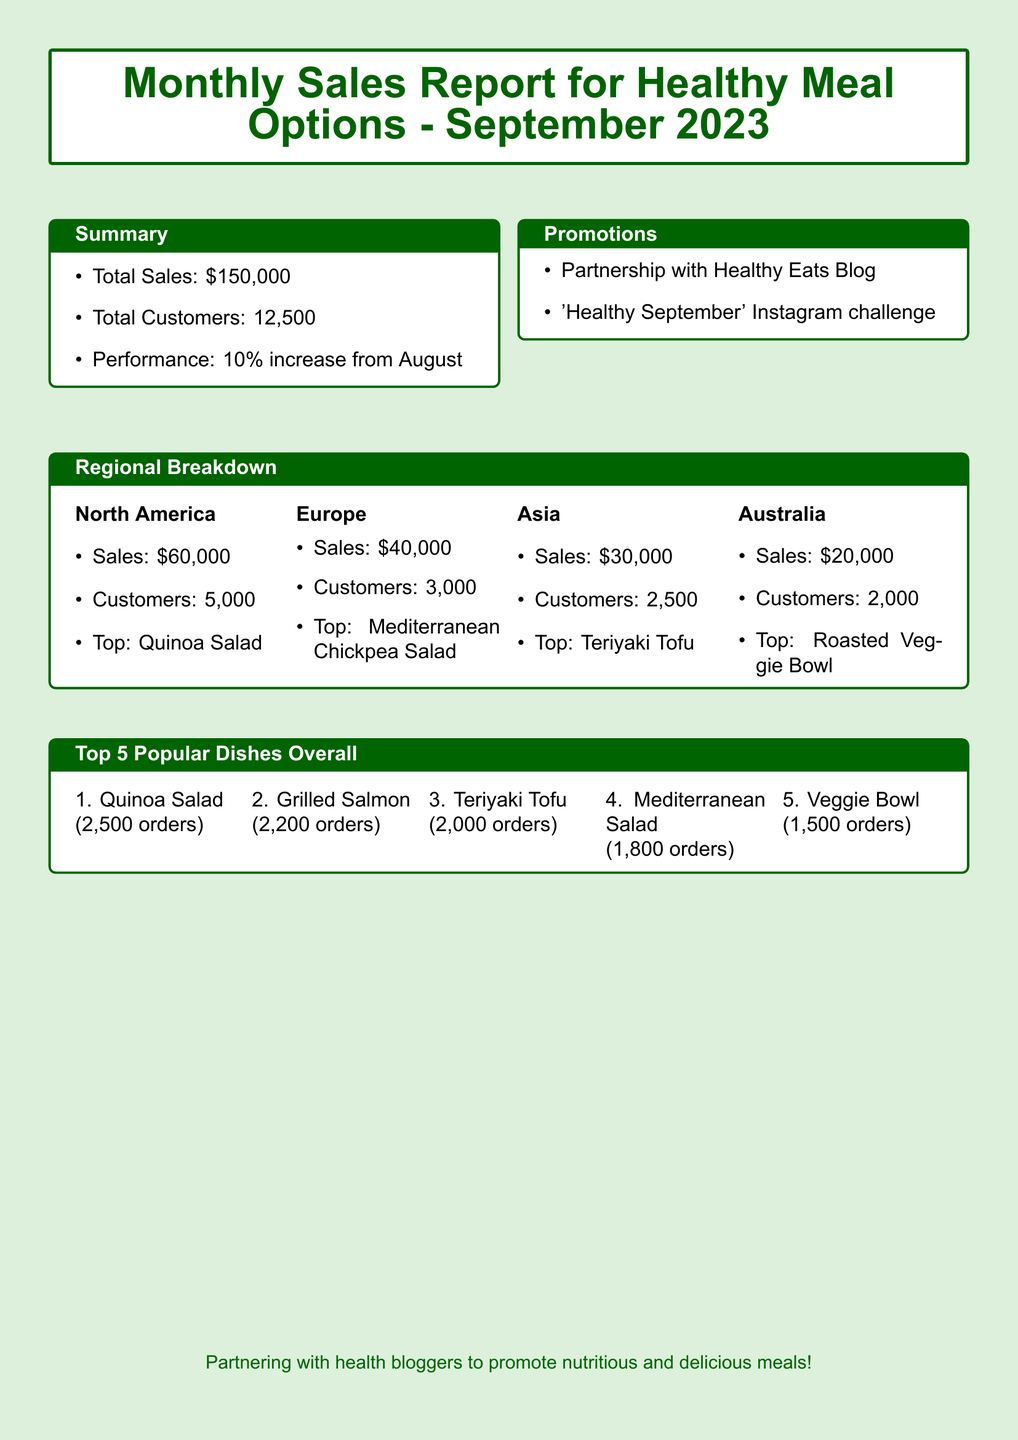What was the total sales in September 2023? The total sales figure is directly provided in the document as $150,000.
Answer: $150,000 How many customers did we serve in September? The total number of customers is mentioned in the summary section of the document.
Answer: 12,500 What is the percentage increase in performance compared to August? The performance increase is specified in the summary as a 10% increase from August.
Answer: 10% Which dish was the top seller in North America? The top-selling dish in the North America region is listed in the regional breakdown section.
Answer: Quinoa Salad What dish had the most orders overall? The top dish overall with the highest number of orders is indicated in the popular dishes section.
Answer: Quinoa Salad How much revenue was generated in Europe? The sales figure for Europe is mentioned under the regional breakdown section.
Answer: $40,000 What was the total sales amount from Australia? The sales figure for Australia is explicitly provided in the regional breakdown section.
Answer: $20,000 Which promotion was highlighted in the report? A promotion that is mentioned in the promotions section of the document.
Answer: 'Healthy September' Instagram challenge How many orders did the Grilled Salmon receive? The number of orders for the Grilled Salmon is stated in the top popular dishes section.
Answer: 2,200 orders 